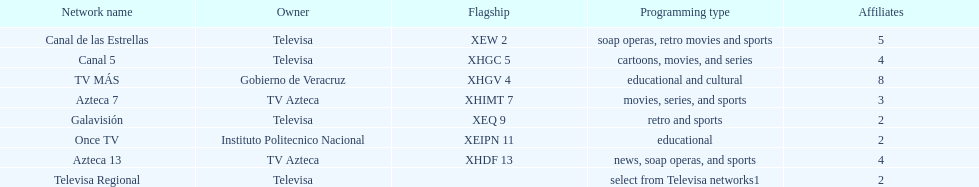How many networks show soap operas? 2. 